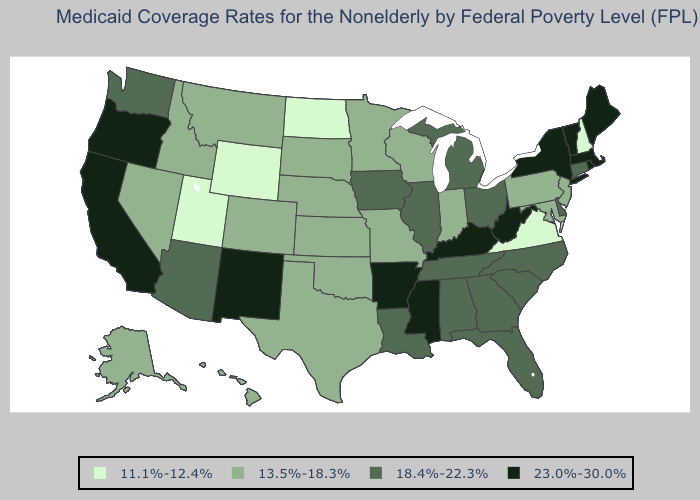Among the states that border Oregon , which have the lowest value?
Answer briefly. Idaho, Nevada. Does Vermont have the lowest value in the USA?
Write a very short answer. No. Among the states that border New Mexico , which have the lowest value?
Answer briefly. Utah. Name the states that have a value in the range 23.0%-30.0%?
Concise answer only. Arkansas, California, Kentucky, Maine, Massachusetts, Mississippi, New Mexico, New York, Oregon, Rhode Island, Vermont, West Virginia. What is the highest value in the Northeast ?
Concise answer only. 23.0%-30.0%. Does the map have missing data?
Answer briefly. No. Among the states that border Vermont , does New York have the lowest value?
Concise answer only. No. Is the legend a continuous bar?
Quick response, please. No. What is the value of Iowa?
Concise answer only. 18.4%-22.3%. Does South Dakota have the lowest value in the USA?
Keep it brief. No. Among the states that border Wisconsin , does Michigan have the highest value?
Concise answer only. Yes. What is the value of Utah?
Give a very brief answer. 11.1%-12.4%. Does Ohio have the highest value in the MidWest?
Be succinct. Yes. Does the map have missing data?
Give a very brief answer. No. Which states have the highest value in the USA?
Be succinct. Arkansas, California, Kentucky, Maine, Massachusetts, Mississippi, New Mexico, New York, Oregon, Rhode Island, Vermont, West Virginia. 